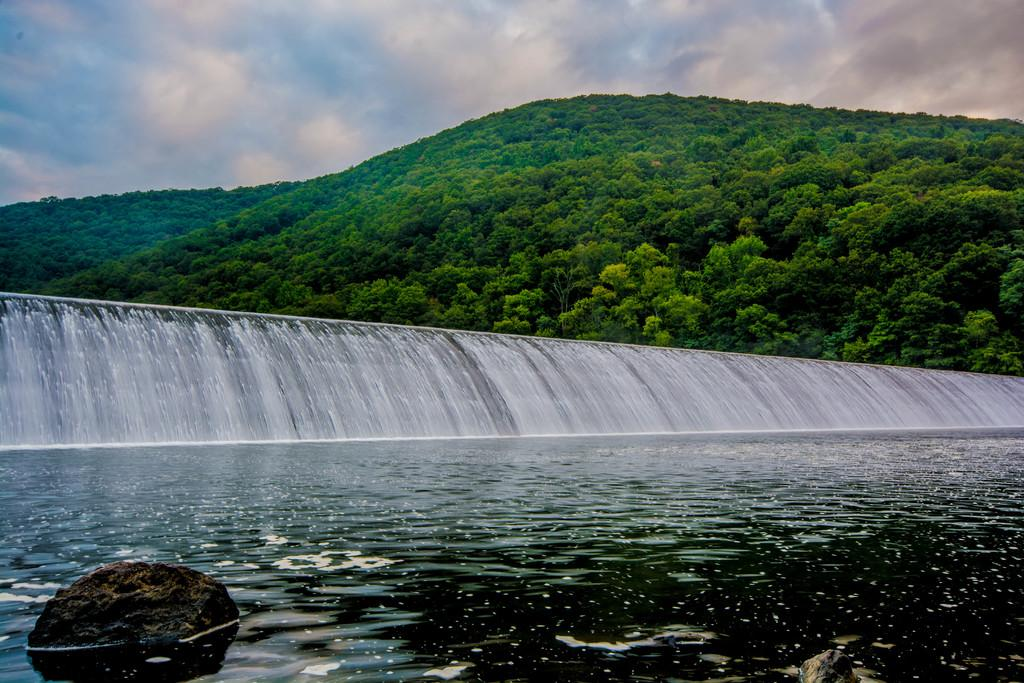What is the primary element in motion in the image? There is water flowing in the image. What type of natural environment can be seen in the background? There are trees in the background of the image. Where is the stone located in the image? The stone is in the bottom left corner of the image. What is visible in the sky at the top of the image? Clouds are visible in the sky at the top of the image. How many men can be seen walking in the image? There are no men present in the image, and therefore no walking can be observed. 